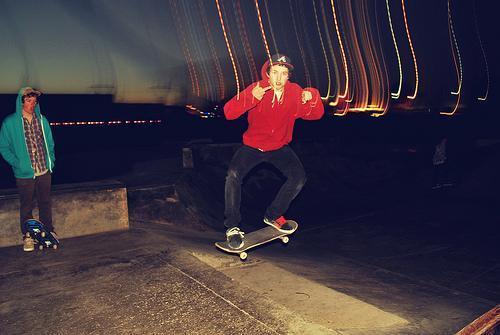How many people are in the picture?
Give a very brief answer. 2. 